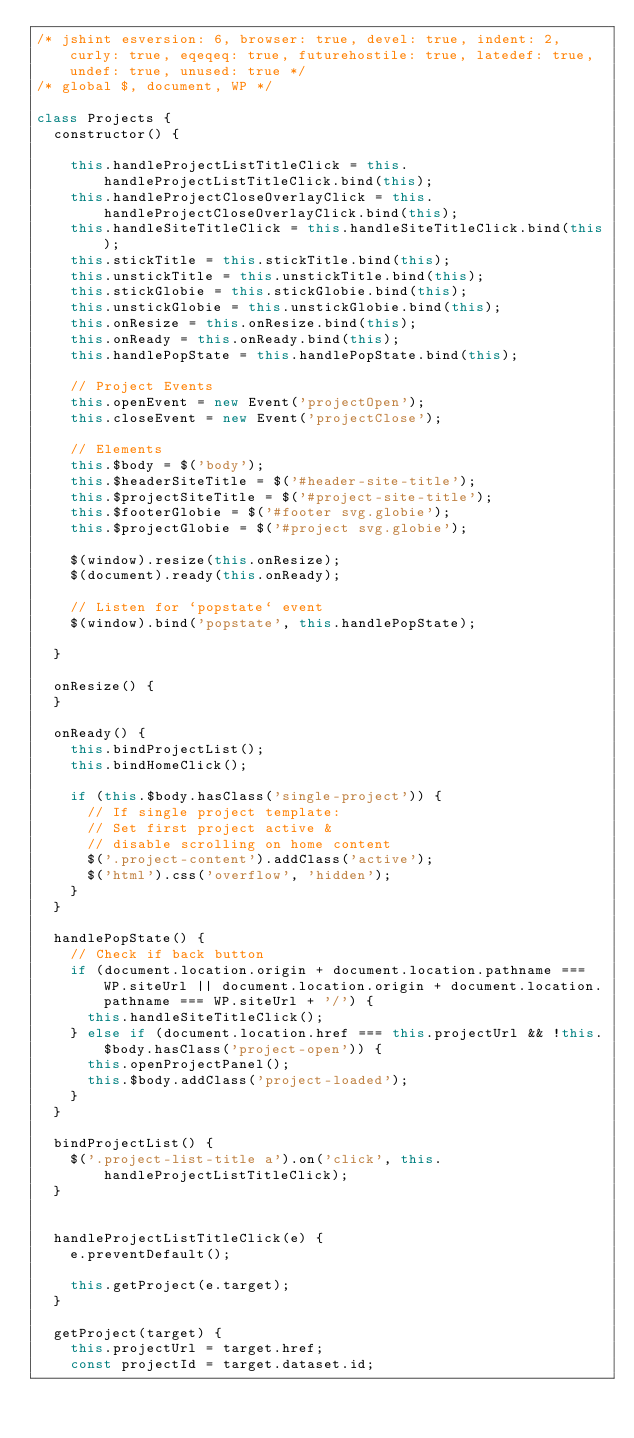<code> <loc_0><loc_0><loc_500><loc_500><_JavaScript_>/* jshint esversion: 6, browser: true, devel: true, indent: 2, curly: true, eqeqeq: true, futurehostile: true, latedef: true, undef: true, unused: true */
/* global $, document, WP */

class Projects {
  constructor() {

    this.handleProjectListTitleClick = this.handleProjectListTitleClick.bind(this);
    this.handleProjectCloseOverlayClick = this.handleProjectCloseOverlayClick.bind(this);
    this.handleSiteTitleClick = this.handleSiteTitleClick.bind(this);
    this.stickTitle = this.stickTitle.bind(this);
    this.unstickTitle = this.unstickTitle.bind(this);
    this.stickGlobie = this.stickGlobie.bind(this);
    this.unstickGlobie = this.unstickGlobie.bind(this);
    this.onResize = this.onResize.bind(this);
    this.onReady = this.onReady.bind(this);
    this.handlePopState = this.handlePopState.bind(this);

    // Project Events
    this.openEvent = new Event('projectOpen');
    this.closeEvent = new Event('projectClose');

    // Elements
    this.$body = $('body');
    this.$headerSiteTitle = $('#header-site-title');
    this.$projectSiteTitle = $('#project-site-title');
    this.$footerGlobie = $('#footer svg.globie');
    this.$projectGlobie = $('#project svg.globie');

    $(window).resize(this.onResize);
    $(document).ready(this.onReady);

    // Listen for `popstate` event
    $(window).bind('popstate', this.handlePopState);

  }

  onResize() {
  }

  onReady() {
    this.bindProjectList();
    this.bindHomeClick();

    if (this.$body.hasClass('single-project')) {
      // If single project template:
      // Set first project active &
      // disable scrolling on home content
      $('.project-content').addClass('active');
      $('html').css('overflow', 'hidden');
    }
  }

  handlePopState() {
    // Check if back button
    if (document.location.origin + document.location.pathname === WP.siteUrl || document.location.origin + document.location.pathname === WP.siteUrl + '/') {
      this.handleSiteTitleClick();
    } else if (document.location.href === this.projectUrl && !this.$body.hasClass('project-open')) {
      this.openProjectPanel();
      this.$body.addClass('project-loaded');
    }
  }

  bindProjectList() {
    $('.project-list-title a').on('click', this.handleProjectListTitleClick);
  }


  handleProjectListTitleClick(e) {
    e.preventDefault();

    this.getProject(e.target);
  }

  getProject(target) {
    this.projectUrl = target.href;
    const projectId = target.dataset.id;
</code> 